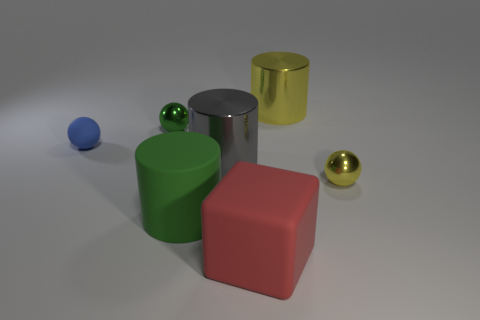Subtract all tiny metallic balls. How many balls are left? 1 Add 1 small objects. How many objects exist? 8 Subtract 1 cylinders. How many cylinders are left? 2 Subtract all cylinders. How many objects are left? 4 Subtract all yellow spheres. Subtract all yellow cylinders. How many spheres are left? 2 Subtract all tiny yellow objects. Subtract all large rubber cylinders. How many objects are left? 5 Add 5 large rubber things. How many large rubber things are left? 7 Add 6 big brown metallic spheres. How many big brown metallic spheres exist? 6 Subtract 0 purple cylinders. How many objects are left? 7 